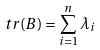<formula> <loc_0><loc_0><loc_500><loc_500>t r ( B ) = \sum _ { i = 1 } ^ { n } \lambda _ { i }</formula> 